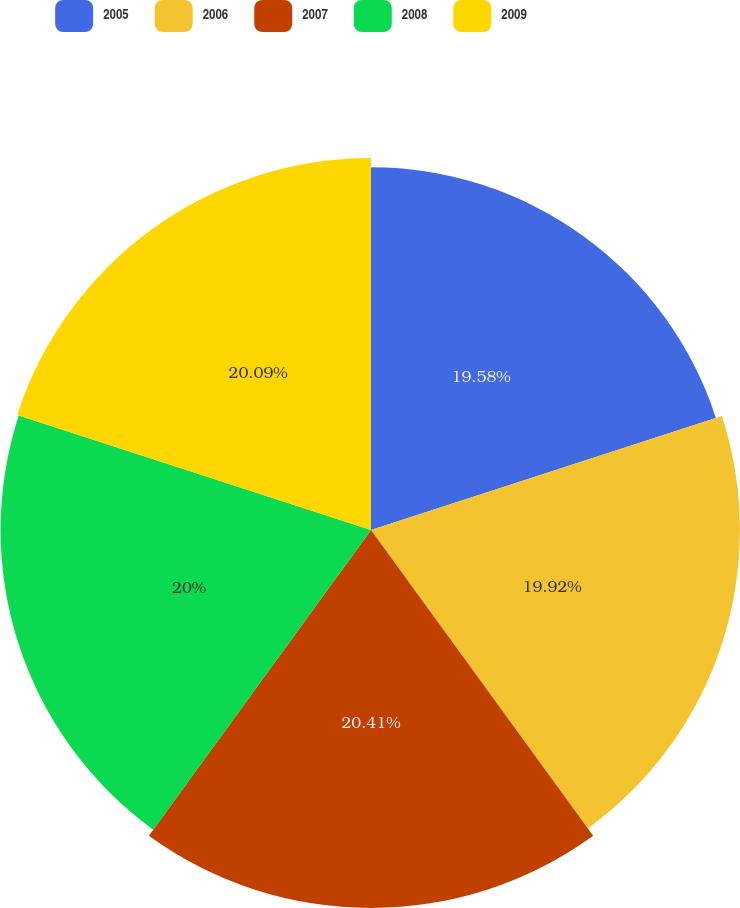Convert chart. <chart><loc_0><loc_0><loc_500><loc_500><pie_chart><fcel>2005<fcel>2006<fcel>2007<fcel>2008<fcel>2009<nl><fcel>19.58%<fcel>19.92%<fcel>20.41%<fcel>20.0%<fcel>20.09%<nl></chart> 